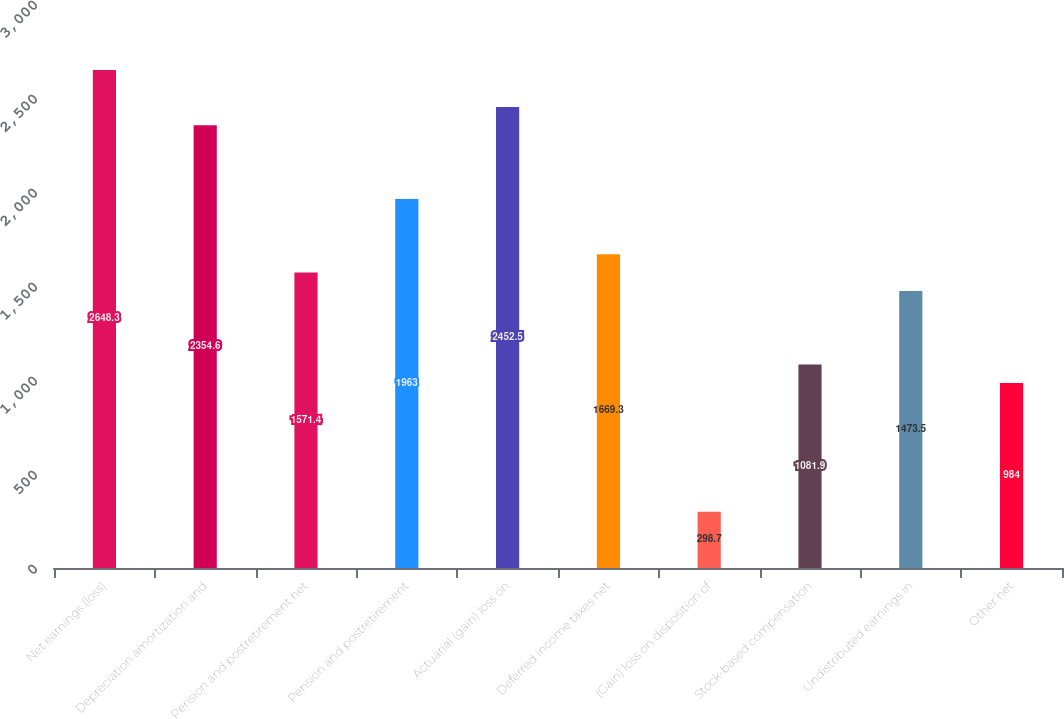<chart> <loc_0><loc_0><loc_500><loc_500><bar_chart><fcel>Net earnings (loss)<fcel>Depreciation amortization and<fcel>Pension and postretirement net<fcel>Pension and postretirement<fcel>Actuarial (gain) loss on<fcel>Deferred income taxes net<fcel>(Gain) loss on disposition of<fcel>Stock-based compensation<fcel>Undistributed earnings in<fcel>Other net<nl><fcel>2648.3<fcel>2354.6<fcel>1571.4<fcel>1963<fcel>2452.5<fcel>1669.3<fcel>298.7<fcel>1081.9<fcel>1473.5<fcel>984<nl></chart> 